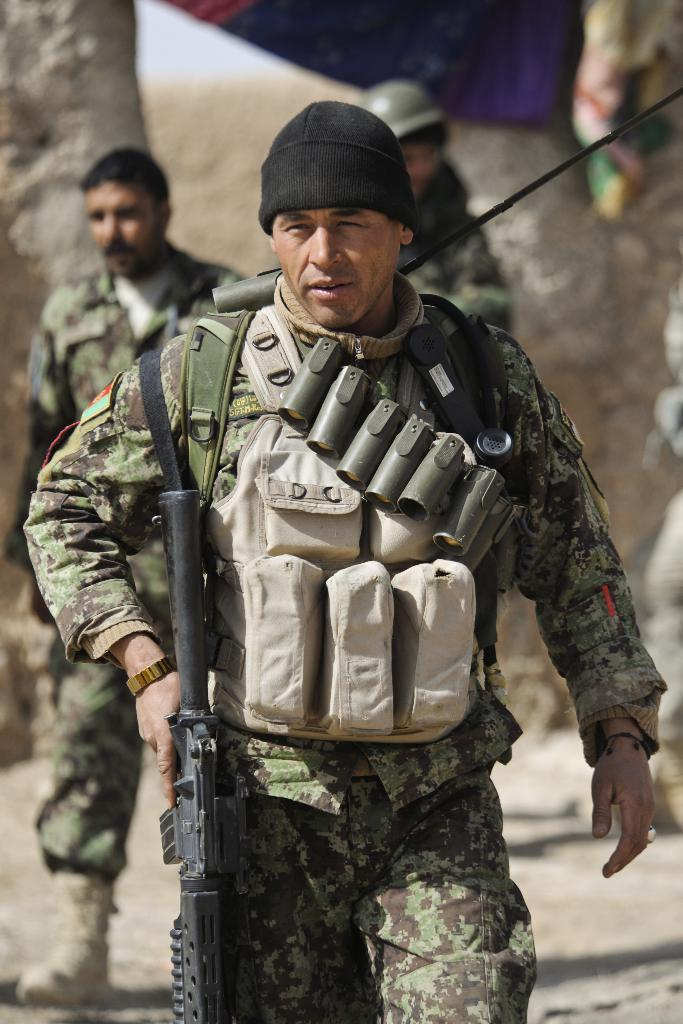What is the person holding in the image? The person is holding a weapon in the image. What accessories is the person wearing? The person is wearing a backpack and a cap. Can you describe the background of the image? The background of the image is blurred. How many people are in the image? There are two people in the image. What else can be seen in the image besides the people? There are objects visible in the image. What type of structure is present in the image? There is a wall in the image. What type of knot is the person using to secure the weapon in the image? There is no knot visible in the image; the person is simply holding the weapon. How many coils of rope can be seen in the image? There is no rope or coils present in the image. Can you describe the behavior of the goose in the image? There is no goose present in the image. 